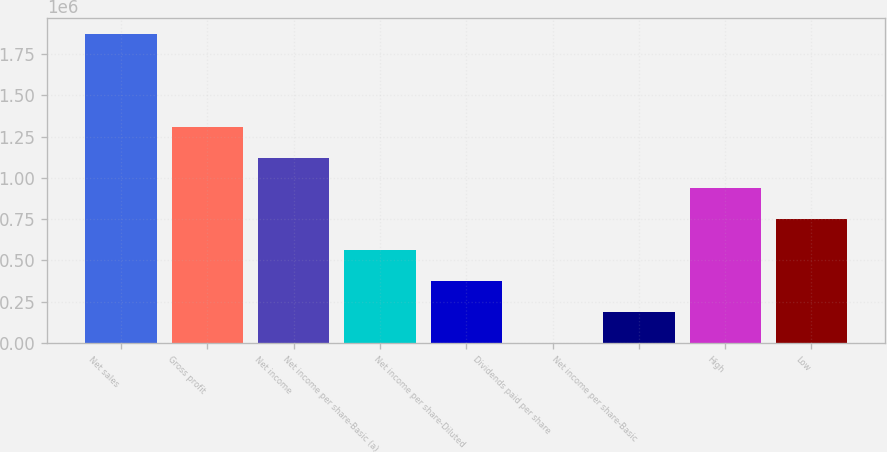Convert chart. <chart><loc_0><loc_0><loc_500><loc_500><bar_chart><fcel>Net sales<fcel>Gross profit<fcel>Net income<fcel>Net income per share-Basic (a)<fcel>Net income per share-Diluted<fcel>Dividends paid per share<fcel>Net income per share-Basic<fcel>High<fcel>Low<nl><fcel>1.87181e+06<fcel>1.31027e+06<fcel>1.12309e+06<fcel>561544<fcel>374363<fcel>0.48<fcel>187182<fcel>935907<fcel>748725<nl></chart> 